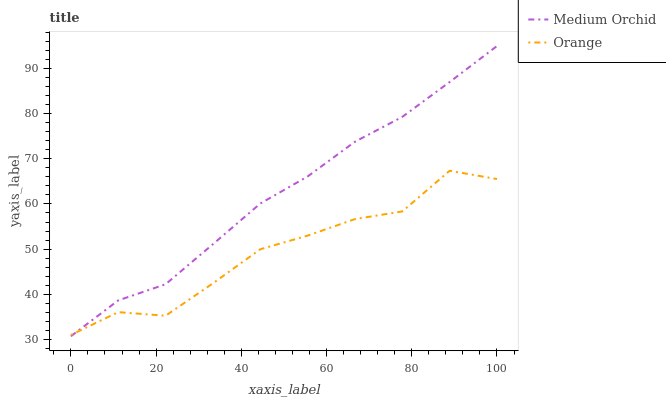Does Orange have the minimum area under the curve?
Answer yes or no. Yes. Does Medium Orchid have the maximum area under the curve?
Answer yes or no. Yes. Does Medium Orchid have the minimum area under the curve?
Answer yes or no. No. Is Medium Orchid the smoothest?
Answer yes or no. Yes. Is Orange the roughest?
Answer yes or no. Yes. Is Medium Orchid the roughest?
Answer yes or no. No. Does Medium Orchid have the lowest value?
Answer yes or no. Yes. Does Medium Orchid have the highest value?
Answer yes or no. Yes. Does Orange intersect Medium Orchid?
Answer yes or no. Yes. Is Orange less than Medium Orchid?
Answer yes or no. No. Is Orange greater than Medium Orchid?
Answer yes or no. No. 